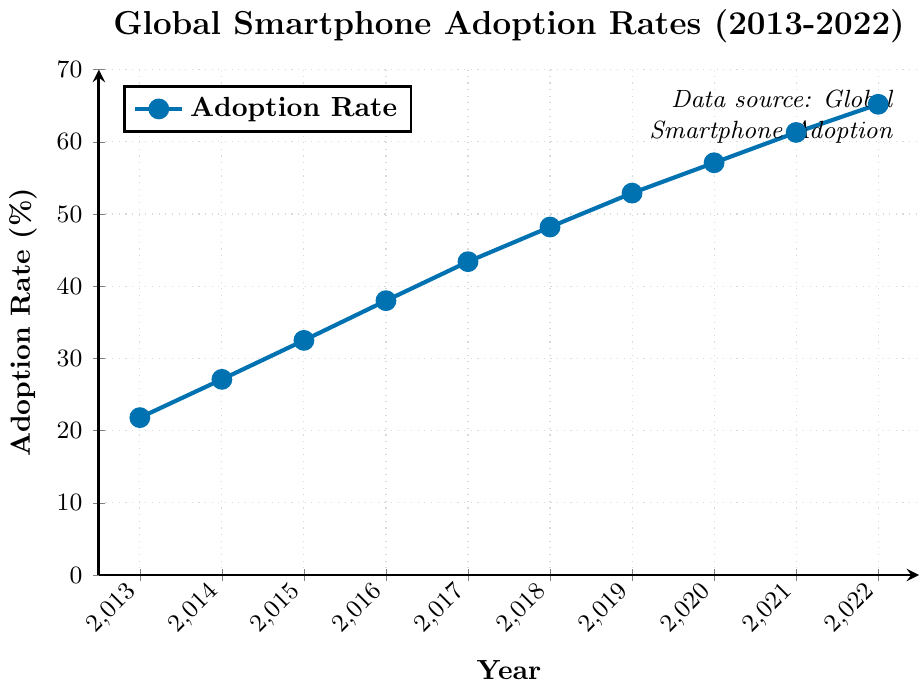What is the overall trend of global smartphone adoption rates from 2013 to 2022? The figure shows a line plot indicating the adoption rates each year from 2013 to 2022. Observing the plotted line, we see that the adoption rates increase every year from 21.8% in 2013 to 65.2% in 2022, showing a consistent upward trend.
Answer: Upward trend Which year had the highest increase in global smartphone adoption rate percentage compared to the previous year? By comparing the differences in adoption rates between consecutive years from the figure: 
- 2013 to 2014: 27.1 - 21.8 = 5.3
- 2014 to 2015: 32.5 - 27.1 = 5.4
- 2015 to 2016: 38.0 - 32.5 = 5.5
- 2016 to 2017: 43.4 - 38.0 = 5.4
- 2017 to 2018: 48.2 - 43.4 = 4.8
- 2018 to 2019: 52.9 - 48.2 = 4.7
- 2019 to 2020: 57.1 - 52.9 = 4.2
- 2020 to 2021: 61.3 - 57.1 = 4.2
- 2021 to 2022: 65.2 - 61.3 = 3.9
The year 2015 to 2016 had the highest increase of 5.5%.
Answer: 2015 to 2016 What is the average global smartphone adoption rate over the period from 2013 to 2022? To find the average adoption rate, sum the adoption rates from 2013 to 2022 and divide by the number of years:
(21.8 + 27.1 + 32.5 + 38.0 + 43.4 + 48.2 + 52.9 + 57.1 + 61.3 + 65.2) / 10 = 44.95%
Answer: 44.95% In which year did the global smartphone adoption rate first exceed 50%? By examining the plotted data points, the adoption rate first exceeds 50% in 2019 with a value of 52.9%.
Answer: 2019 Compare the global smartphone adoption rates of 2013 and 2022. How much did the adoption rate increase over this period? The adoption rate in 2013 is 21.8% and in 2022 is 65.2%. The increase is 65.2% - 21.8% = 43.4%.
Answer: 43.4% By what percentage did the global smartphone adoption rate increase from 2019 to 2022? The adoption rate in 2019 is 52.9% and in 2022 is 65.2%. The increase is 65.2% - 52.9% = 12.3%.
Answer: 12.3% Which year had the lowest global smartphone adoption rate? Referencing the figure, the year 2013 had the lowest adoption rate at 21.8%.
Answer: 2013 What is the visual representation color of the smartphone adoption trend line in the figure? The trend line representing the smartphone adoption rate is colored blue.
Answer: Blue 